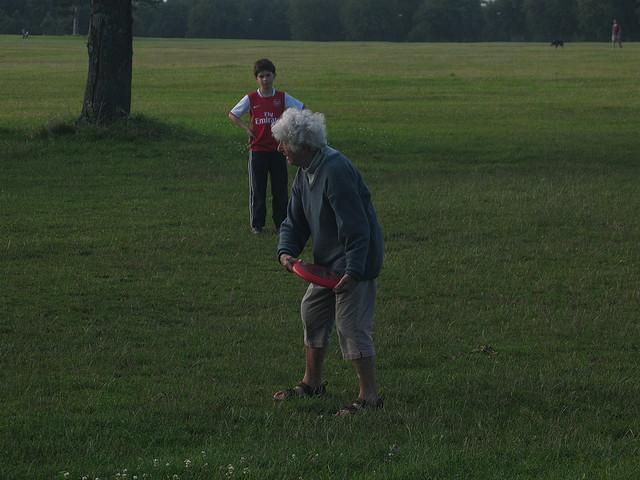How many people in this photo?
Give a very brief answer. 2. How many people are in the photo?
Give a very brief answer. 2. How many people have red shirts?
Give a very brief answer. 1. How many people are there?
Give a very brief answer. 2. 